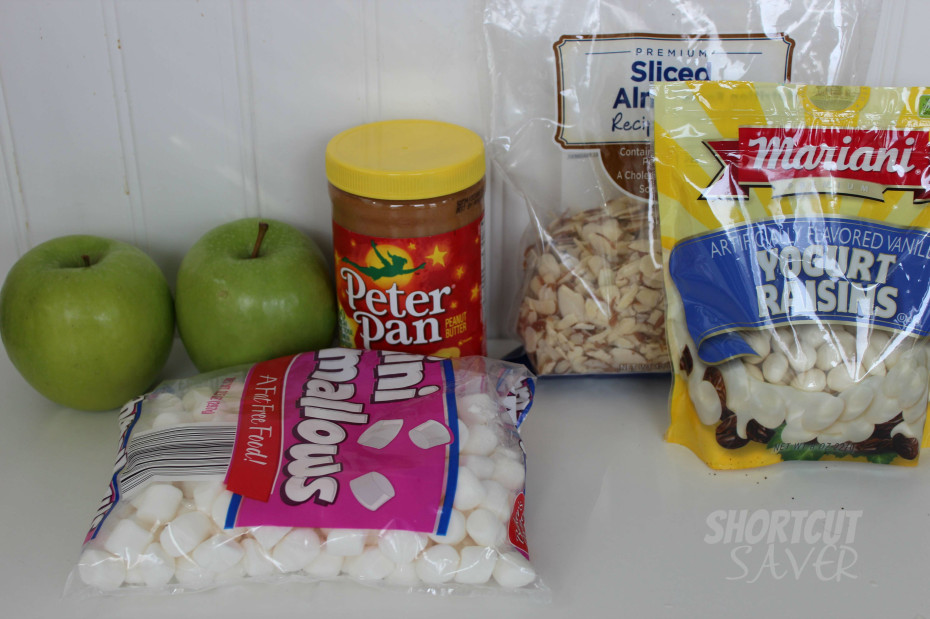Given the combination of items, what kind of recipe or dish might be intended to be prepared with these ingredients? Based on the combination of items presented—apples, peanut butter, mini marshmallows, sliced almonds, and yogurt-covered raisins—a possible recipe or dish that might be intended for preparation could be a dessert or a sweet snack mix. These ingredients could be used to make a fruit salad with a sweet dressing or a dessert pizza with a peanut butter base, topped with sliced apples, marshmallows, almonds, and yogurt raisins. Another possibility is creating apple sandwiches with peanut butter and the other items as fillings, or simply a sweet trail mix combining all the ingredients. 